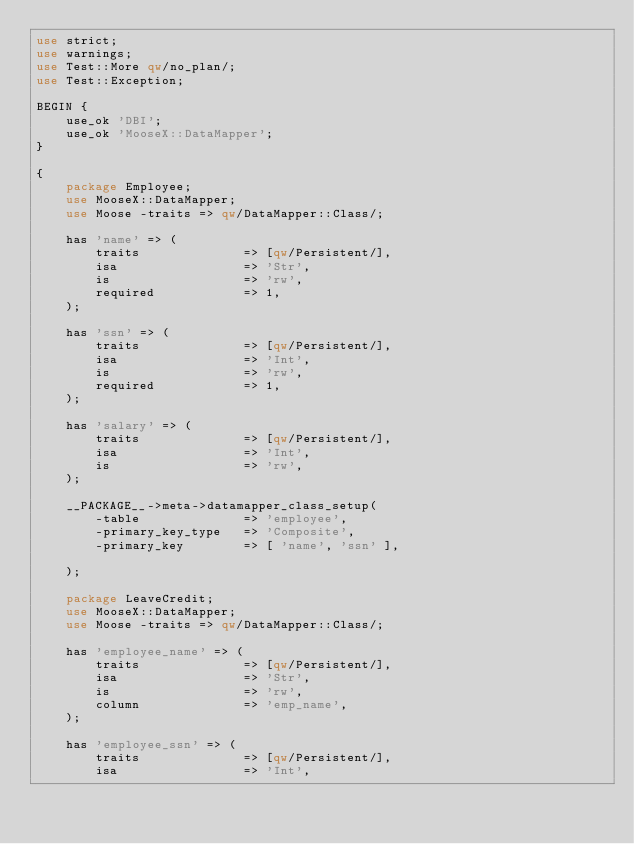<code> <loc_0><loc_0><loc_500><loc_500><_Perl_>use strict;
use warnings;
use Test::More qw/no_plan/;
use Test::Exception;

BEGIN {
    use_ok 'DBI';
    use_ok 'MooseX::DataMapper';
}

{
    package Employee;
    use MooseX::DataMapper;
    use Moose -traits => qw/DataMapper::Class/;

    has 'name' => (
        traits              => [qw/Persistent/],
        isa                 => 'Str',
        is                  => 'rw',
        required            => 1,
    );

    has 'ssn' => (
        traits              => [qw/Persistent/],
        isa                 => 'Int',
        is                  => 'rw',
        required            => 1,
    );

    has 'salary' => (
        traits              => [qw/Persistent/],
        isa                 => 'Int',
        is                  => 'rw',
    );

    __PACKAGE__->meta->datamapper_class_setup(
        -table              => 'employee',
        -primary_key_type   => 'Composite',
        -primary_key        => [ 'name', 'ssn' ],
        
    );

    package LeaveCredit;
    use MooseX::DataMapper;
    use Moose -traits => qw/DataMapper::Class/;

    has 'employee_name' => (
        traits              => [qw/Persistent/],
        isa                 => 'Str',
        is                  => 'rw',
        column              => 'emp_name',
    );

    has 'employee_ssn' => (
        traits              => [qw/Persistent/],
        isa                 => 'Int',</code> 